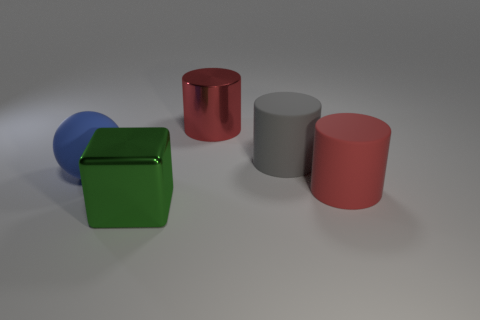What is the size of the thing that is the same color as the big metal cylinder?
Your answer should be compact. Large. There is a large red object that is in front of the red cylinder that is behind the large blue object; what number of large objects are behind it?
Your answer should be very brief. 3. Is the color of the large shiny cylinder the same as the big matte ball?
Make the answer very short. No. Are there any other matte spheres of the same color as the rubber ball?
Provide a succinct answer. No. There is a metal block that is the same size as the metallic cylinder; what is its color?
Provide a succinct answer. Green. Is there another red shiny object that has the same shape as the large red metal object?
Your answer should be very brief. No. There is a matte thing that is the same color as the big shiny cylinder; what shape is it?
Your answer should be compact. Cylinder. There is a large shiny thing that is behind the large red object in front of the blue matte object; is there a big blue rubber sphere that is behind it?
Keep it short and to the point. No. What is the shape of the blue object that is the same size as the green metal object?
Give a very brief answer. Sphere. What color is the other rubber object that is the same shape as the gray object?
Your answer should be compact. Red. 